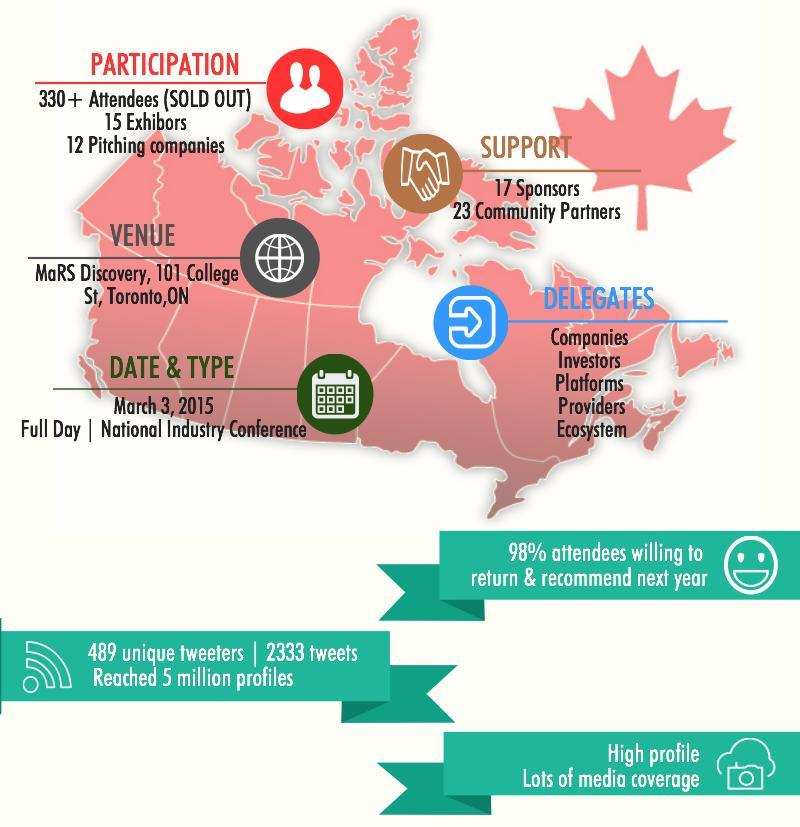How many exhibitors are participating in the National Industry Conference organised in Toronto?
Answer the question with a short phrase. 15 Exhibitors What is the duration of the National Industry Conference organised in Toronto? Full Day When was the National Industry Conference conducted in Toronto? MARCH 3, 2015 How many people were attending the National Industry Conference organised in Toronto? 330+ What percent of the conference attendees are not willing to return & recommend for the next year? 2% How many community partners were involved in organising the National Industry Conference? 23 Community Partners 